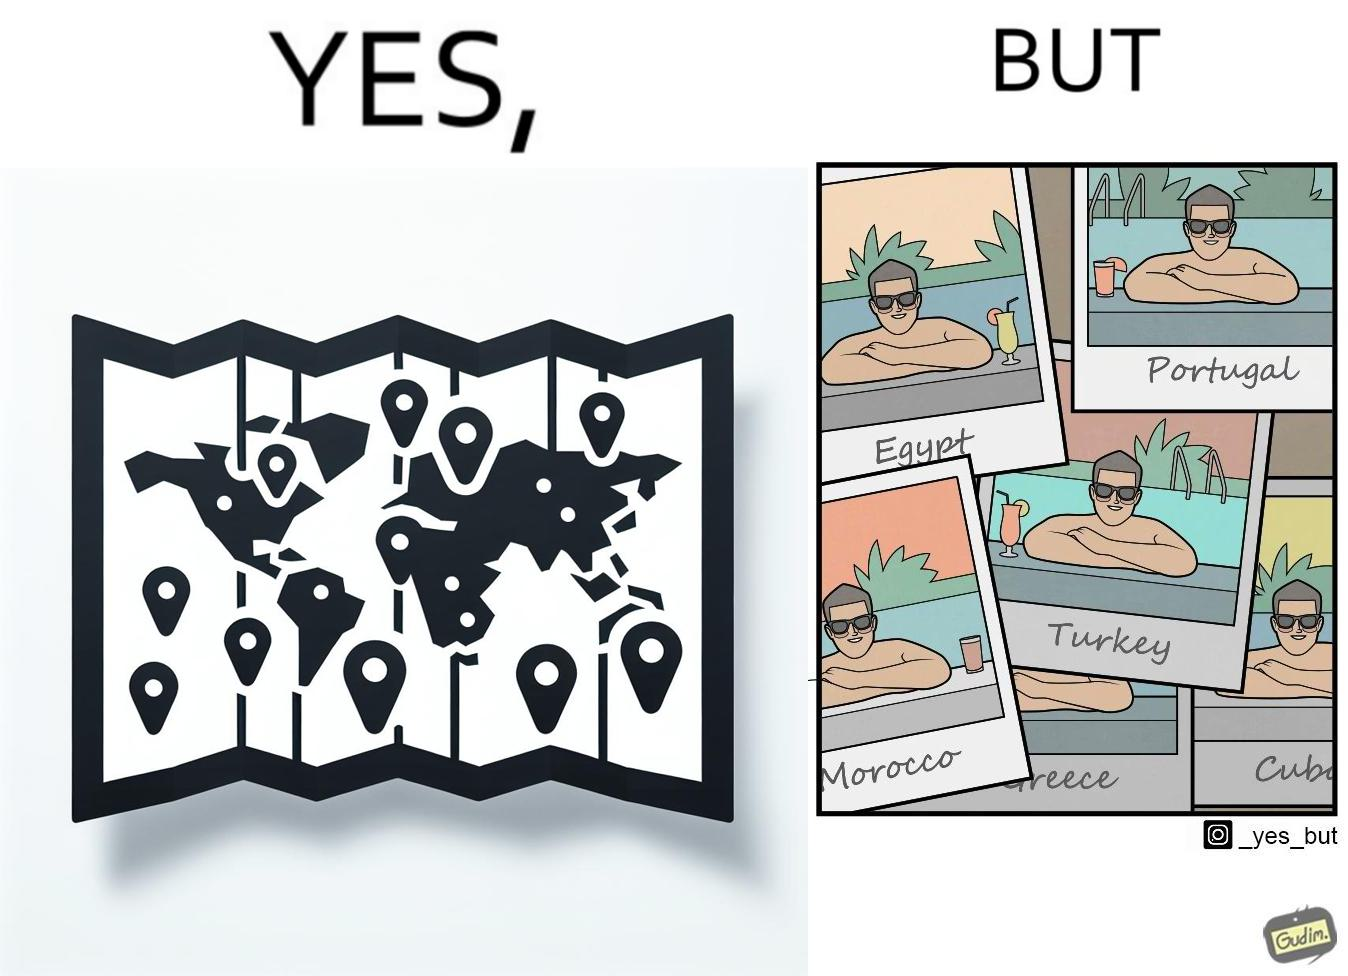Would you classify this image as satirical? Yes, this image is satirical. 